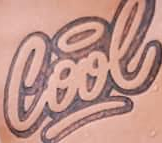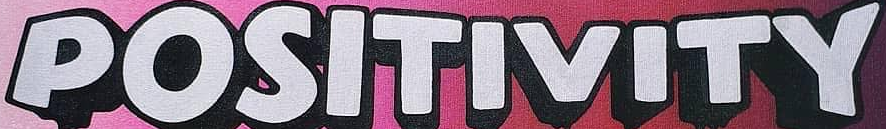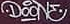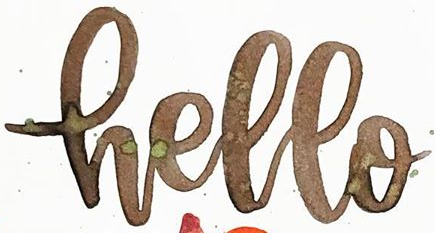What text appears in these images from left to right, separated by a semicolon? Cool; POSITIVITY; DOONE; Hello 